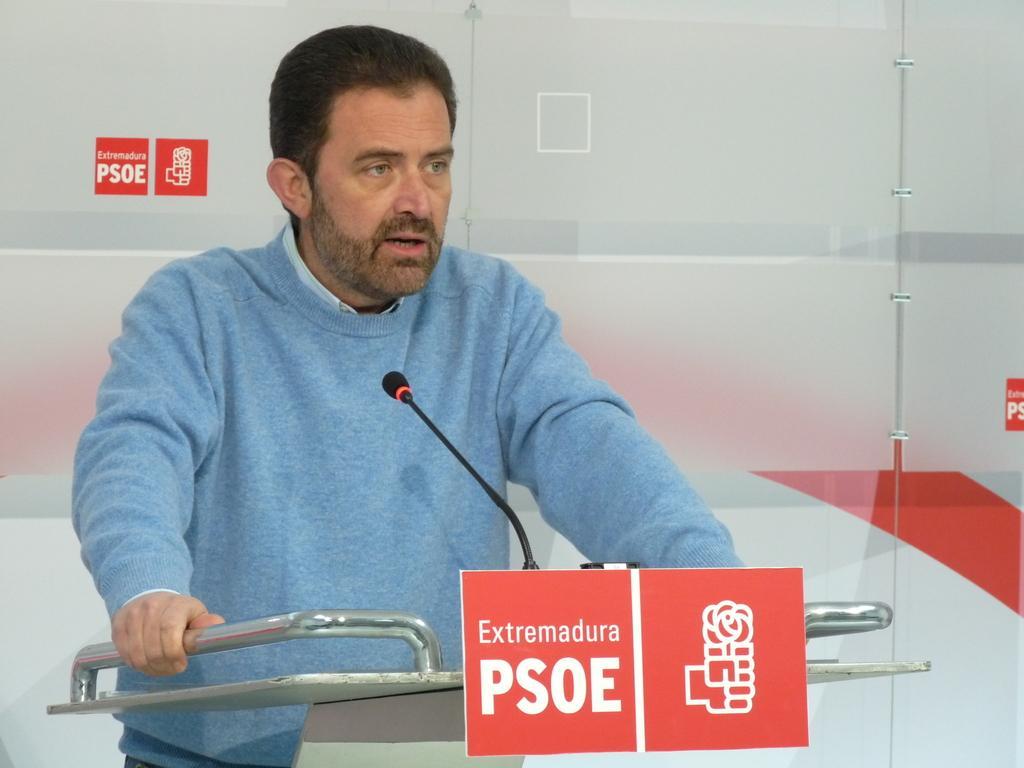Please provide a concise description of this image. In the center of this picture there is a man wearing blue color sweater and standing behind a podium and we can see a microphone, metal rods and the text on the posters. 